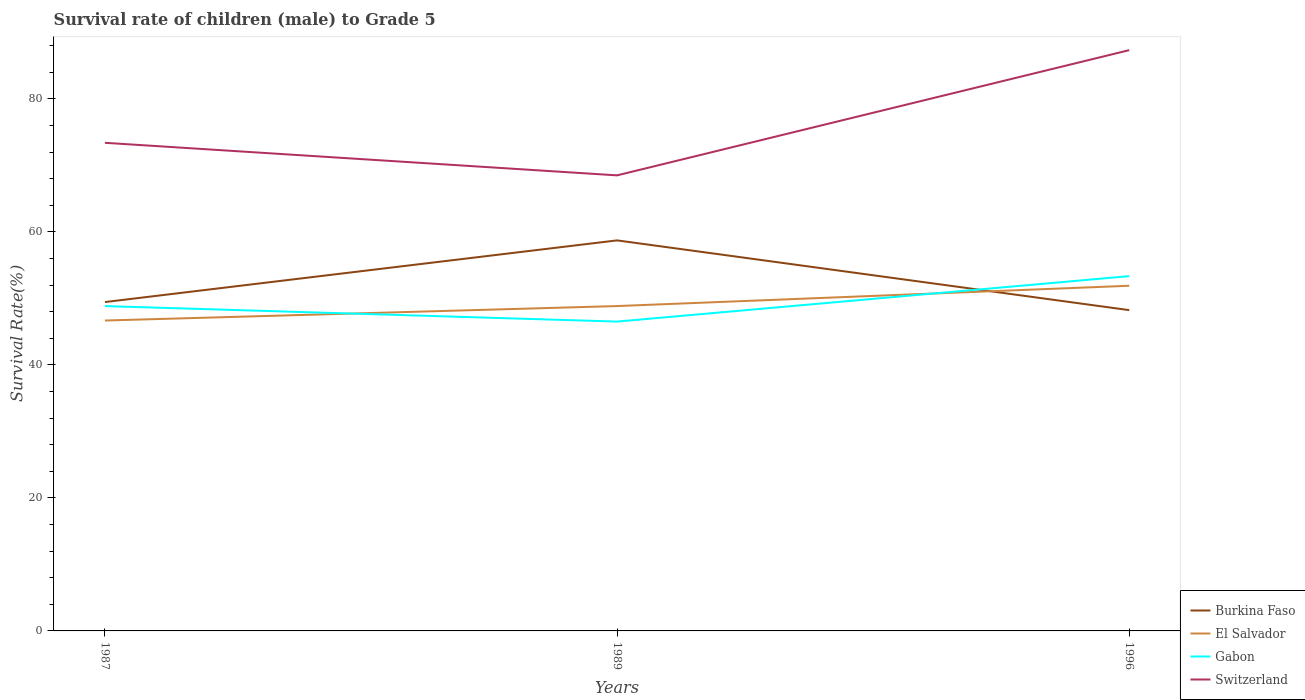How many different coloured lines are there?
Your answer should be compact. 4. Across all years, what is the maximum survival rate of male children to grade 5 in Switzerland?
Provide a succinct answer. 68.49. What is the total survival rate of male children to grade 5 in El Salvador in the graph?
Provide a succinct answer. -2.17. What is the difference between the highest and the second highest survival rate of male children to grade 5 in Burkina Faso?
Keep it short and to the point. 10.49. What is the difference between the highest and the lowest survival rate of male children to grade 5 in Gabon?
Your answer should be compact. 1. Is the survival rate of male children to grade 5 in Gabon strictly greater than the survival rate of male children to grade 5 in Switzerland over the years?
Your answer should be very brief. Yes. What is the difference between two consecutive major ticks on the Y-axis?
Keep it short and to the point. 20. Are the values on the major ticks of Y-axis written in scientific E-notation?
Offer a terse response. No. Does the graph contain any zero values?
Ensure brevity in your answer.  No. Does the graph contain grids?
Provide a succinct answer. No. What is the title of the graph?
Your answer should be very brief. Survival rate of children (male) to Grade 5. Does "Low & middle income" appear as one of the legend labels in the graph?
Keep it short and to the point. No. What is the label or title of the X-axis?
Keep it short and to the point. Years. What is the label or title of the Y-axis?
Keep it short and to the point. Survival Rate(%). What is the Survival Rate(%) of Burkina Faso in 1987?
Give a very brief answer. 49.44. What is the Survival Rate(%) of El Salvador in 1987?
Offer a terse response. 46.67. What is the Survival Rate(%) of Gabon in 1987?
Your answer should be very brief. 48.84. What is the Survival Rate(%) in Switzerland in 1987?
Make the answer very short. 73.39. What is the Survival Rate(%) in Burkina Faso in 1989?
Give a very brief answer. 58.72. What is the Survival Rate(%) in El Salvador in 1989?
Give a very brief answer. 48.84. What is the Survival Rate(%) of Gabon in 1989?
Make the answer very short. 46.51. What is the Survival Rate(%) of Switzerland in 1989?
Make the answer very short. 68.49. What is the Survival Rate(%) in Burkina Faso in 1996?
Offer a very short reply. 48.23. What is the Survival Rate(%) in El Salvador in 1996?
Provide a succinct answer. 51.89. What is the Survival Rate(%) in Gabon in 1996?
Provide a succinct answer. 53.34. What is the Survival Rate(%) in Switzerland in 1996?
Keep it short and to the point. 87.32. Across all years, what is the maximum Survival Rate(%) in Burkina Faso?
Ensure brevity in your answer.  58.72. Across all years, what is the maximum Survival Rate(%) in El Salvador?
Make the answer very short. 51.89. Across all years, what is the maximum Survival Rate(%) in Gabon?
Your answer should be compact. 53.34. Across all years, what is the maximum Survival Rate(%) in Switzerland?
Offer a very short reply. 87.32. Across all years, what is the minimum Survival Rate(%) of Burkina Faso?
Give a very brief answer. 48.23. Across all years, what is the minimum Survival Rate(%) in El Salvador?
Keep it short and to the point. 46.67. Across all years, what is the minimum Survival Rate(%) in Gabon?
Provide a short and direct response. 46.51. Across all years, what is the minimum Survival Rate(%) of Switzerland?
Provide a short and direct response. 68.49. What is the total Survival Rate(%) in Burkina Faso in the graph?
Give a very brief answer. 156.39. What is the total Survival Rate(%) in El Salvador in the graph?
Your answer should be compact. 147.4. What is the total Survival Rate(%) of Gabon in the graph?
Ensure brevity in your answer.  148.69. What is the total Survival Rate(%) of Switzerland in the graph?
Offer a very short reply. 229.19. What is the difference between the Survival Rate(%) of Burkina Faso in 1987 and that in 1989?
Make the answer very short. -9.27. What is the difference between the Survival Rate(%) of El Salvador in 1987 and that in 1989?
Ensure brevity in your answer.  -2.17. What is the difference between the Survival Rate(%) in Gabon in 1987 and that in 1989?
Ensure brevity in your answer.  2.33. What is the difference between the Survival Rate(%) of Switzerland in 1987 and that in 1989?
Offer a terse response. 4.89. What is the difference between the Survival Rate(%) in Burkina Faso in 1987 and that in 1996?
Your answer should be compact. 1.21. What is the difference between the Survival Rate(%) in El Salvador in 1987 and that in 1996?
Your response must be concise. -5.23. What is the difference between the Survival Rate(%) in Gabon in 1987 and that in 1996?
Your answer should be very brief. -4.5. What is the difference between the Survival Rate(%) in Switzerland in 1987 and that in 1996?
Your answer should be compact. -13.93. What is the difference between the Survival Rate(%) in Burkina Faso in 1989 and that in 1996?
Ensure brevity in your answer.  10.49. What is the difference between the Survival Rate(%) in El Salvador in 1989 and that in 1996?
Keep it short and to the point. -3.05. What is the difference between the Survival Rate(%) of Gabon in 1989 and that in 1996?
Your answer should be compact. -6.83. What is the difference between the Survival Rate(%) of Switzerland in 1989 and that in 1996?
Your answer should be very brief. -18.83. What is the difference between the Survival Rate(%) in Burkina Faso in 1987 and the Survival Rate(%) in El Salvador in 1989?
Make the answer very short. 0.6. What is the difference between the Survival Rate(%) in Burkina Faso in 1987 and the Survival Rate(%) in Gabon in 1989?
Provide a succinct answer. 2.94. What is the difference between the Survival Rate(%) in Burkina Faso in 1987 and the Survival Rate(%) in Switzerland in 1989?
Provide a succinct answer. -19.05. What is the difference between the Survival Rate(%) of El Salvador in 1987 and the Survival Rate(%) of Gabon in 1989?
Make the answer very short. 0.16. What is the difference between the Survival Rate(%) of El Salvador in 1987 and the Survival Rate(%) of Switzerland in 1989?
Give a very brief answer. -21.82. What is the difference between the Survival Rate(%) of Gabon in 1987 and the Survival Rate(%) of Switzerland in 1989?
Your response must be concise. -19.65. What is the difference between the Survival Rate(%) in Burkina Faso in 1987 and the Survival Rate(%) in El Salvador in 1996?
Your answer should be very brief. -2.45. What is the difference between the Survival Rate(%) in Burkina Faso in 1987 and the Survival Rate(%) in Gabon in 1996?
Provide a short and direct response. -3.9. What is the difference between the Survival Rate(%) of Burkina Faso in 1987 and the Survival Rate(%) of Switzerland in 1996?
Offer a terse response. -37.87. What is the difference between the Survival Rate(%) of El Salvador in 1987 and the Survival Rate(%) of Gabon in 1996?
Your response must be concise. -6.67. What is the difference between the Survival Rate(%) in El Salvador in 1987 and the Survival Rate(%) in Switzerland in 1996?
Give a very brief answer. -40.65. What is the difference between the Survival Rate(%) in Gabon in 1987 and the Survival Rate(%) in Switzerland in 1996?
Keep it short and to the point. -38.48. What is the difference between the Survival Rate(%) in Burkina Faso in 1989 and the Survival Rate(%) in El Salvador in 1996?
Your answer should be compact. 6.82. What is the difference between the Survival Rate(%) in Burkina Faso in 1989 and the Survival Rate(%) in Gabon in 1996?
Keep it short and to the point. 5.38. What is the difference between the Survival Rate(%) of Burkina Faso in 1989 and the Survival Rate(%) of Switzerland in 1996?
Offer a terse response. -28.6. What is the difference between the Survival Rate(%) in El Salvador in 1989 and the Survival Rate(%) in Gabon in 1996?
Make the answer very short. -4.5. What is the difference between the Survival Rate(%) of El Salvador in 1989 and the Survival Rate(%) of Switzerland in 1996?
Give a very brief answer. -38.47. What is the difference between the Survival Rate(%) in Gabon in 1989 and the Survival Rate(%) in Switzerland in 1996?
Make the answer very short. -40.81. What is the average Survival Rate(%) in Burkina Faso per year?
Your answer should be very brief. 52.13. What is the average Survival Rate(%) of El Salvador per year?
Ensure brevity in your answer.  49.13. What is the average Survival Rate(%) of Gabon per year?
Give a very brief answer. 49.56. What is the average Survival Rate(%) in Switzerland per year?
Ensure brevity in your answer.  76.4. In the year 1987, what is the difference between the Survival Rate(%) in Burkina Faso and Survival Rate(%) in El Salvador?
Offer a terse response. 2.78. In the year 1987, what is the difference between the Survival Rate(%) in Burkina Faso and Survival Rate(%) in Gabon?
Provide a short and direct response. 0.6. In the year 1987, what is the difference between the Survival Rate(%) in Burkina Faso and Survival Rate(%) in Switzerland?
Your answer should be very brief. -23.94. In the year 1987, what is the difference between the Survival Rate(%) in El Salvador and Survival Rate(%) in Gabon?
Ensure brevity in your answer.  -2.17. In the year 1987, what is the difference between the Survival Rate(%) in El Salvador and Survival Rate(%) in Switzerland?
Your answer should be compact. -26.72. In the year 1987, what is the difference between the Survival Rate(%) in Gabon and Survival Rate(%) in Switzerland?
Your answer should be very brief. -24.55. In the year 1989, what is the difference between the Survival Rate(%) in Burkina Faso and Survival Rate(%) in El Salvador?
Keep it short and to the point. 9.87. In the year 1989, what is the difference between the Survival Rate(%) of Burkina Faso and Survival Rate(%) of Gabon?
Provide a succinct answer. 12.21. In the year 1989, what is the difference between the Survival Rate(%) in Burkina Faso and Survival Rate(%) in Switzerland?
Your answer should be compact. -9.77. In the year 1989, what is the difference between the Survival Rate(%) in El Salvador and Survival Rate(%) in Gabon?
Offer a very short reply. 2.33. In the year 1989, what is the difference between the Survival Rate(%) in El Salvador and Survival Rate(%) in Switzerland?
Make the answer very short. -19.65. In the year 1989, what is the difference between the Survival Rate(%) in Gabon and Survival Rate(%) in Switzerland?
Your answer should be very brief. -21.98. In the year 1996, what is the difference between the Survival Rate(%) of Burkina Faso and Survival Rate(%) of El Salvador?
Your answer should be compact. -3.66. In the year 1996, what is the difference between the Survival Rate(%) in Burkina Faso and Survival Rate(%) in Gabon?
Your answer should be very brief. -5.11. In the year 1996, what is the difference between the Survival Rate(%) of Burkina Faso and Survival Rate(%) of Switzerland?
Provide a short and direct response. -39.09. In the year 1996, what is the difference between the Survival Rate(%) of El Salvador and Survival Rate(%) of Gabon?
Provide a succinct answer. -1.45. In the year 1996, what is the difference between the Survival Rate(%) of El Salvador and Survival Rate(%) of Switzerland?
Your answer should be very brief. -35.42. In the year 1996, what is the difference between the Survival Rate(%) of Gabon and Survival Rate(%) of Switzerland?
Your answer should be compact. -33.98. What is the ratio of the Survival Rate(%) in Burkina Faso in 1987 to that in 1989?
Make the answer very short. 0.84. What is the ratio of the Survival Rate(%) in El Salvador in 1987 to that in 1989?
Your answer should be very brief. 0.96. What is the ratio of the Survival Rate(%) of Gabon in 1987 to that in 1989?
Provide a succinct answer. 1.05. What is the ratio of the Survival Rate(%) of Switzerland in 1987 to that in 1989?
Provide a succinct answer. 1.07. What is the ratio of the Survival Rate(%) in Burkina Faso in 1987 to that in 1996?
Provide a succinct answer. 1.03. What is the ratio of the Survival Rate(%) in El Salvador in 1987 to that in 1996?
Your answer should be compact. 0.9. What is the ratio of the Survival Rate(%) in Gabon in 1987 to that in 1996?
Ensure brevity in your answer.  0.92. What is the ratio of the Survival Rate(%) of Switzerland in 1987 to that in 1996?
Keep it short and to the point. 0.84. What is the ratio of the Survival Rate(%) of Burkina Faso in 1989 to that in 1996?
Your answer should be very brief. 1.22. What is the ratio of the Survival Rate(%) in Gabon in 1989 to that in 1996?
Provide a succinct answer. 0.87. What is the ratio of the Survival Rate(%) of Switzerland in 1989 to that in 1996?
Offer a very short reply. 0.78. What is the difference between the highest and the second highest Survival Rate(%) in Burkina Faso?
Provide a succinct answer. 9.27. What is the difference between the highest and the second highest Survival Rate(%) of El Salvador?
Provide a short and direct response. 3.05. What is the difference between the highest and the second highest Survival Rate(%) in Gabon?
Provide a succinct answer. 4.5. What is the difference between the highest and the second highest Survival Rate(%) of Switzerland?
Your answer should be very brief. 13.93. What is the difference between the highest and the lowest Survival Rate(%) of Burkina Faso?
Provide a short and direct response. 10.49. What is the difference between the highest and the lowest Survival Rate(%) in El Salvador?
Your response must be concise. 5.23. What is the difference between the highest and the lowest Survival Rate(%) of Gabon?
Keep it short and to the point. 6.83. What is the difference between the highest and the lowest Survival Rate(%) of Switzerland?
Your answer should be very brief. 18.83. 